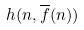<formula> <loc_0><loc_0><loc_500><loc_500>h ( n , \overline { f } ( n ) )</formula> 